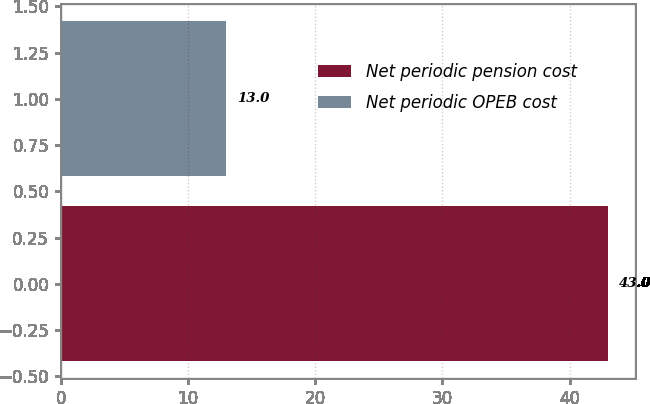<chart> <loc_0><loc_0><loc_500><loc_500><bar_chart><fcel>Net periodic pension cost<fcel>Net periodic OPEB cost<nl><fcel>43<fcel>13<nl></chart> 